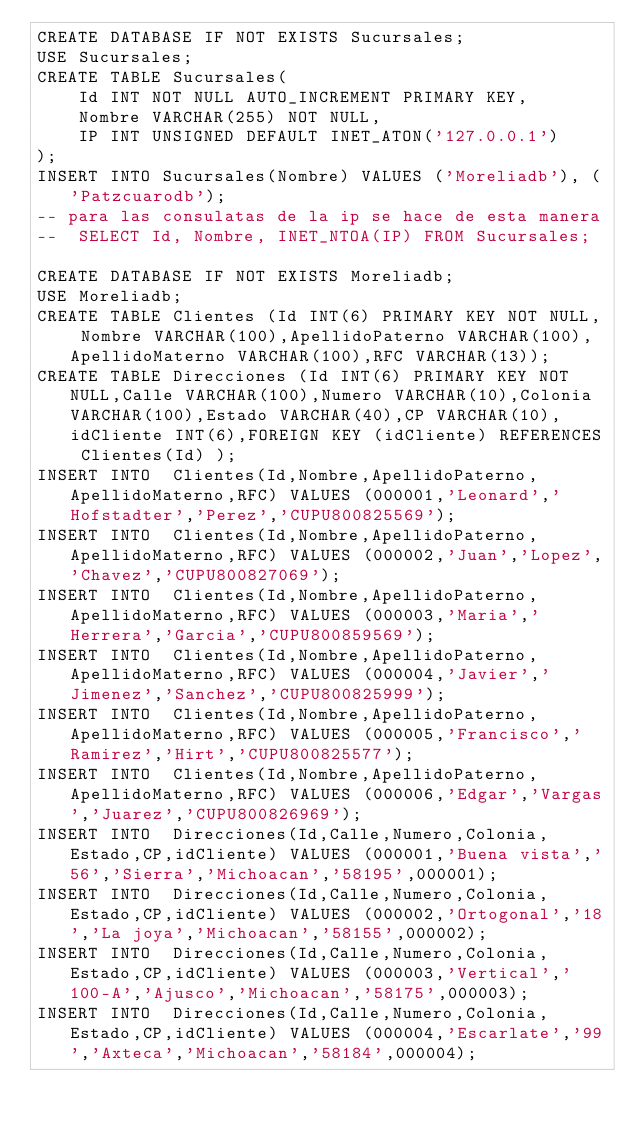Convert code to text. <code><loc_0><loc_0><loc_500><loc_500><_SQL_>CREATE DATABASE IF NOT EXISTS Sucursales;
USE Sucursales;
CREATE TABLE Sucursales(
    Id INT NOT NULL AUTO_INCREMENT PRIMARY KEY,
    Nombre VARCHAR(255) NOT NULL,
    IP INT UNSIGNED DEFAULT INET_ATON('127.0.0.1')
);
INSERT INTO Sucursales(Nombre) VALUES ('Moreliadb'), ('Patzcuarodb');
-- para las consulatas de la ip se hace de esta manera
--  SELECT Id, Nombre, INET_NTOA(IP) FROM Sucursales;

CREATE DATABASE IF NOT EXISTS Moreliadb;
USE Moreliadb;
CREATE TABLE Clientes (Id INT(6) PRIMARY KEY NOT NULL, Nombre VARCHAR(100),ApellidoPaterno VARCHAR(100),ApellidoMaterno VARCHAR(100),RFC VARCHAR(13));
CREATE TABLE Direcciones (Id INT(6) PRIMARY KEY NOT NULL,Calle VARCHAR(100),Numero VARCHAR(10),Colonia VARCHAR(100),Estado VARCHAR(40),CP VARCHAR(10),idCliente INT(6),FOREIGN KEY (idCliente) REFERENCES Clientes(Id) );
INSERT INTO  Clientes(Id,Nombre,ApellidoPaterno,ApellidoMaterno,RFC) VALUES (000001,'Leonard','Hofstadter','Perez','CUPU800825569');
INSERT INTO  Clientes(Id,Nombre,ApellidoPaterno,ApellidoMaterno,RFC) VALUES (000002,'Juan','Lopez','Chavez','CUPU800827069');
INSERT INTO  Clientes(Id,Nombre,ApellidoPaterno,ApellidoMaterno,RFC) VALUES (000003,'Maria','Herrera','Garcia','CUPU800859569');
INSERT INTO  Clientes(Id,Nombre,ApellidoPaterno,ApellidoMaterno,RFC) VALUES (000004,'Javier','Jimenez','Sanchez','CUPU800825999');
INSERT INTO  Clientes(Id,Nombre,ApellidoPaterno,ApellidoMaterno,RFC) VALUES (000005,'Francisco','Ramirez','Hirt','CUPU800825577');
INSERT INTO  Clientes(Id,Nombre,ApellidoPaterno,ApellidoMaterno,RFC) VALUES (000006,'Edgar','Vargas','Juarez','CUPU800826969');
INSERT INTO  Direcciones(Id,Calle,Numero,Colonia,Estado,CP,idCliente) VALUES (000001,'Buena vista','56','Sierra','Michoacan','58195',000001);
INSERT INTO  Direcciones(Id,Calle,Numero,Colonia,Estado,CP,idCliente) VALUES (000002,'Ortogonal','18','La joya','Michoacan','58155',000002);
INSERT INTO  Direcciones(Id,Calle,Numero,Colonia,Estado,CP,idCliente) VALUES (000003,'Vertical','100-A','Ajusco','Michoacan','58175',000003);
INSERT INTO  Direcciones(Id,Calle,Numero,Colonia,Estado,CP,idCliente) VALUES (000004,'Escarlate','99','Axteca','Michoacan','58184',000004);</code> 